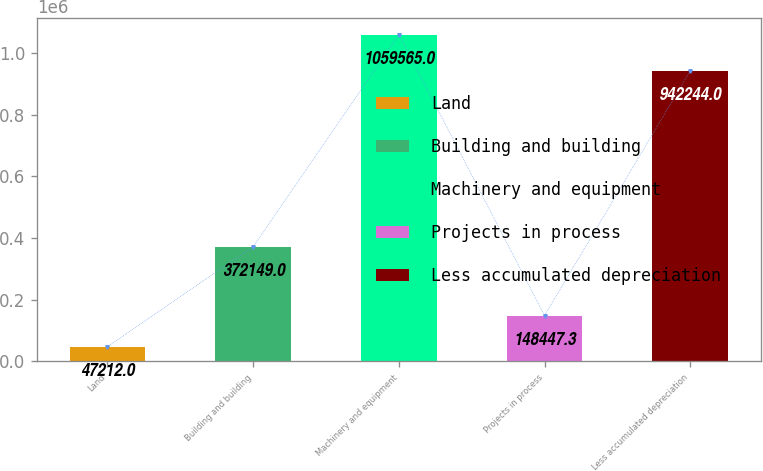<chart> <loc_0><loc_0><loc_500><loc_500><bar_chart><fcel>Land<fcel>Building and building<fcel>Machinery and equipment<fcel>Projects in process<fcel>Less accumulated depreciation<nl><fcel>47212<fcel>372149<fcel>1.05956e+06<fcel>148447<fcel>942244<nl></chart> 